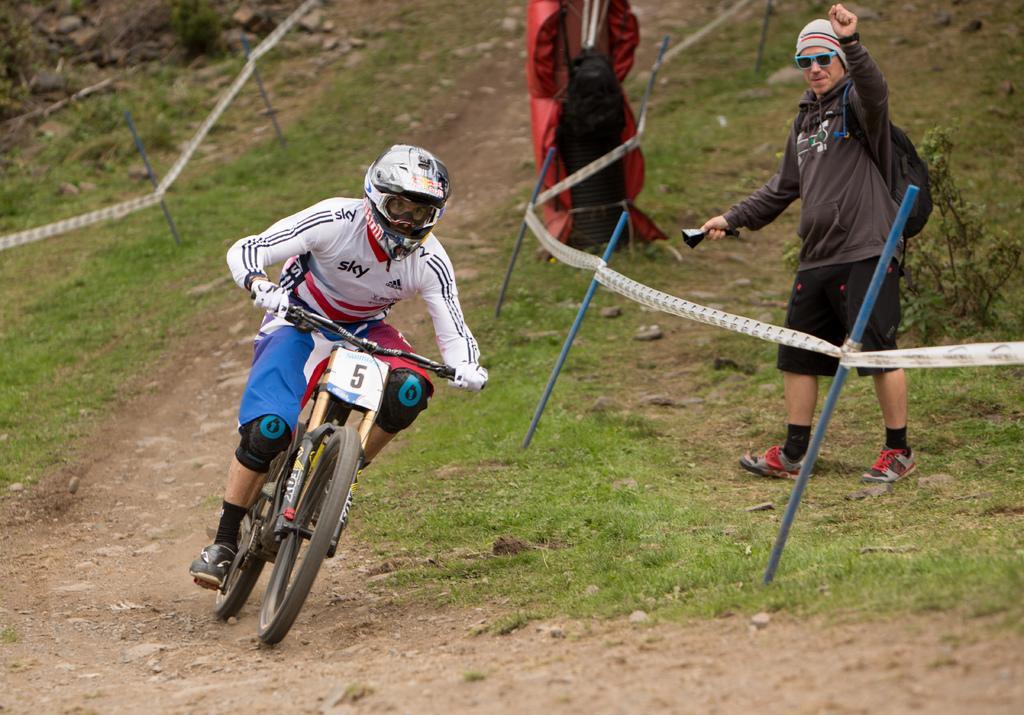In one or two sentences, can you explain what this image depicts? In this image there is a person riding a bicycle on the path. On the right and left side of the image there is a fence. On the right side of the image there is a person standing and there is an object. 